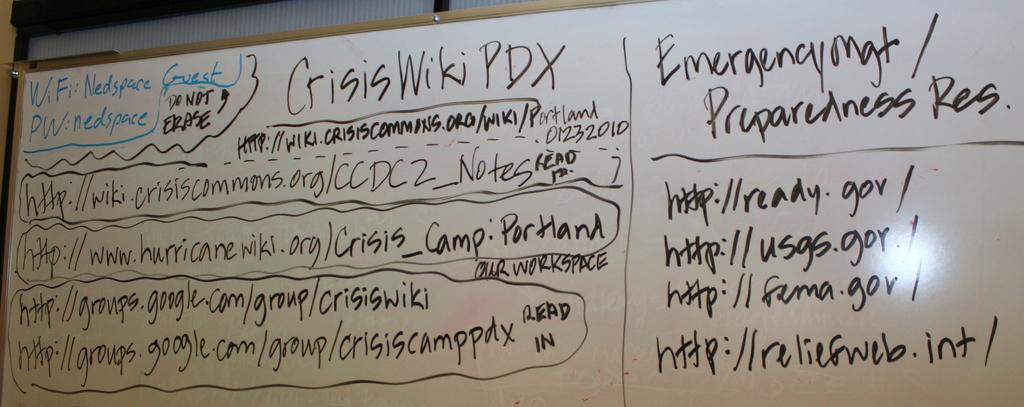Provide a one-sentence caption for the provided image. Nedspace is the Guest WiFi and nedspace is the password. 